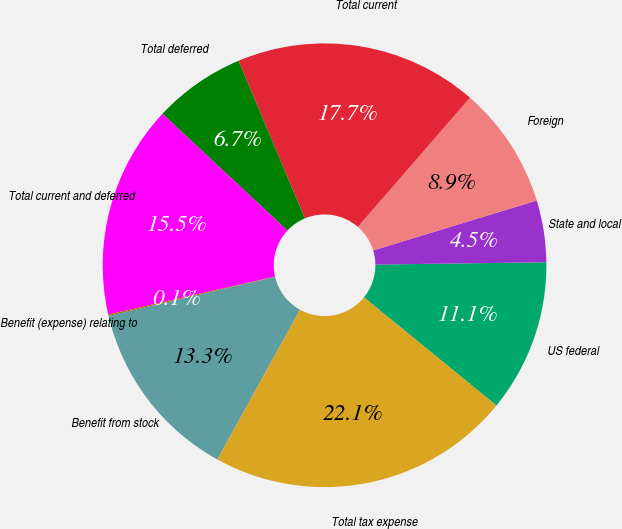Convert chart to OTSL. <chart><loc_0><loc_0><loc_500><loc_500><pie_chart><fcel>US federal<fcel>State and local<fcel>Foreign<fcel>Total current<fcel>Total deferred<fcel>Total current and deferred<fcel>Benefit (expense) relating to<fcel>Benefit from stock<fcel>Total tax expense<nl><fcel>11.11%<fcel>4.5%<fcel>8.91%<fcel>17.72%<fcel>6.71%<fcel>15.52%<fcel>0.1%<fcel>13.31%<fcel>22.13%<nl></chart> 